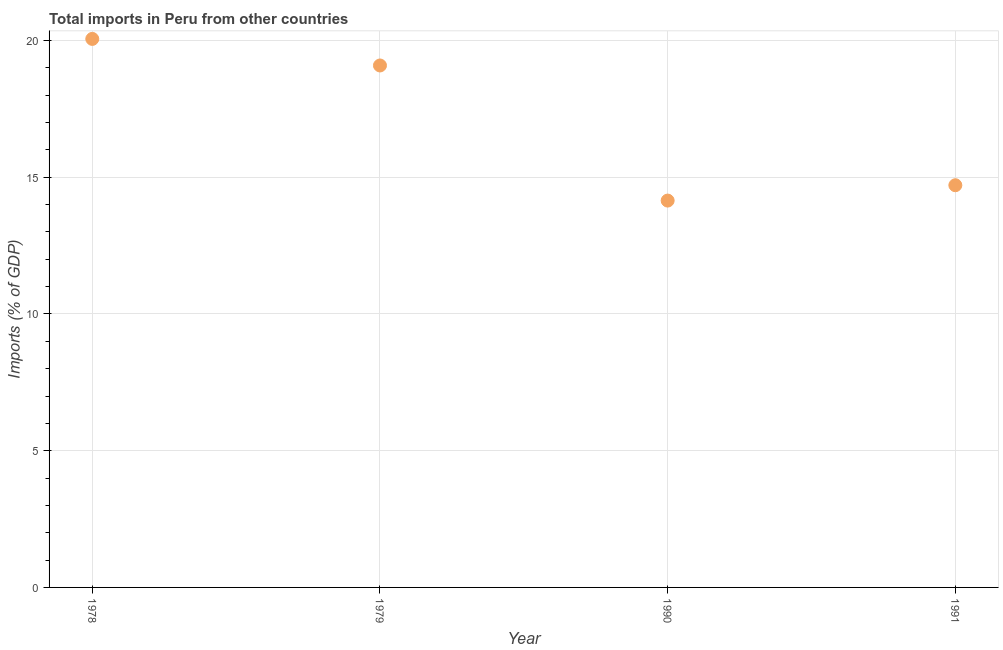What is the total imports in 1978?
Provide a short and direct response. 20.06. Across all years, what is the maximum total imports?
Keep it short and to the point. 20.06. Across all years, what is the minimum total imports?
Provide a succinct answer. 14.15. In which year was the total imports maximum?
Provide a succinct answer. 1978. In which year was the total imports minimum?
Make the answer very short. 1990. What is the sum of the total imports?
Your response must be concise. 68. What is the difference between the total imports in 1978 and 1979?
Provide a short and direct response. 0.97. What is the average total imports per year?
Provide a short and direct response. 17. What is the median total imports?
Make the answer very short. 16.9. In how many years, is the total imports greater than 12 %?
Ensure brevity in your answer.  4. Do a majority of the years between 1990 and 1991 (inclusive) have total imports greater than 16 %?
Your answer should be very brief. No. What is the ratio of the total imports in 1979 to that in 1990?
Ensure brevity in your answer.  1.35. Is the total imports in 1978 less than that in 1990?
Your answer should be very brief. No. What is the difference between the highest and the second highest total imports?
Offer a terse response. 0.97. What is the difference between the highest and the lowest total imports?
Your response must be concise. 5.91. Does the total imports monotonically increase over the years?
Offer a very short reply. No. How many years are there in the graph?
Your answer should be compact. 4. What is the difference between two consecutive major ticks on the Y-axis?
Offer a very short reply. 5. Are the values on the major ticks of Y-axis written in scientific E-notation?
Keep it short and to the point. No. Does the graph contain any zero values?
Offer a terse response. No. Does the graph contain grids?
Your answer should be very brief. Yes. What is the title of the graph?
Keep it short and to the point. Total imports in Peru from other countries. What is the label or title of the X-axis?
Your response must be concise. Year. What is the label or title of the Y-axis?
Your response must be concise. Imports (% of GDP). What is the Imports (% of GDP) in 1978?
Keep it short and to the point. 20.06. What is the Imports (% of GDP) in 1979?
Offer a terse response. 19.09. What is the Imports (% of GDP) in 1990?
Offer a terse response. 14.15. What is the Imports (% of GDP) in 1991?
Your answer should be compact. 14.71. What is the difference between the Imports (% of GDP) in 1978 and 1979?
Provide a succinct answer. 0.97. What is the difference between the Imports (% of GDP) in 1978 and 1990?
Give a very brief answer. 5.91. What is the difference between the Imports (% of GDP) in 1978 and 1991?
Give a very brief answer. 5.35. What is the difference between the Imports (% of GDP) in 1979 and 1990?
Provide a short and direct response. 4.94. What is the difference between the Imports (% of GDP) in 1979 and 1991?
Your answer should be very brief. 4.38. What is the difference between the Imports (% of GDP) in 1990 and 1991?
Keep it short and to the point. -0.56. What is the ratio of the Imports (% of GDP) in 1978 to that in 1979?
Provide a succinct answer. 1.05. What is the ratio of the Imports (% of GDP) in 1978 to that in 1990?
Your answer should be compact. 1.42. What is the ratio of the Imports (% of GDP) in 1978 to that in 1991?
Keep it short and to the point. 1.36. What is the ratio of the Imports (% of GDP) in 1979 to that in 1990?
Give a very brief answer. 1.35. What is the ratio of the Imports (% of GDP) in 1979 to that in 1991?
Offer a terse response. 1.3. What is the ratio of the Imports (% of GDP) in 1990 to that in 1991?
Give a very brief answer. 0.96. 